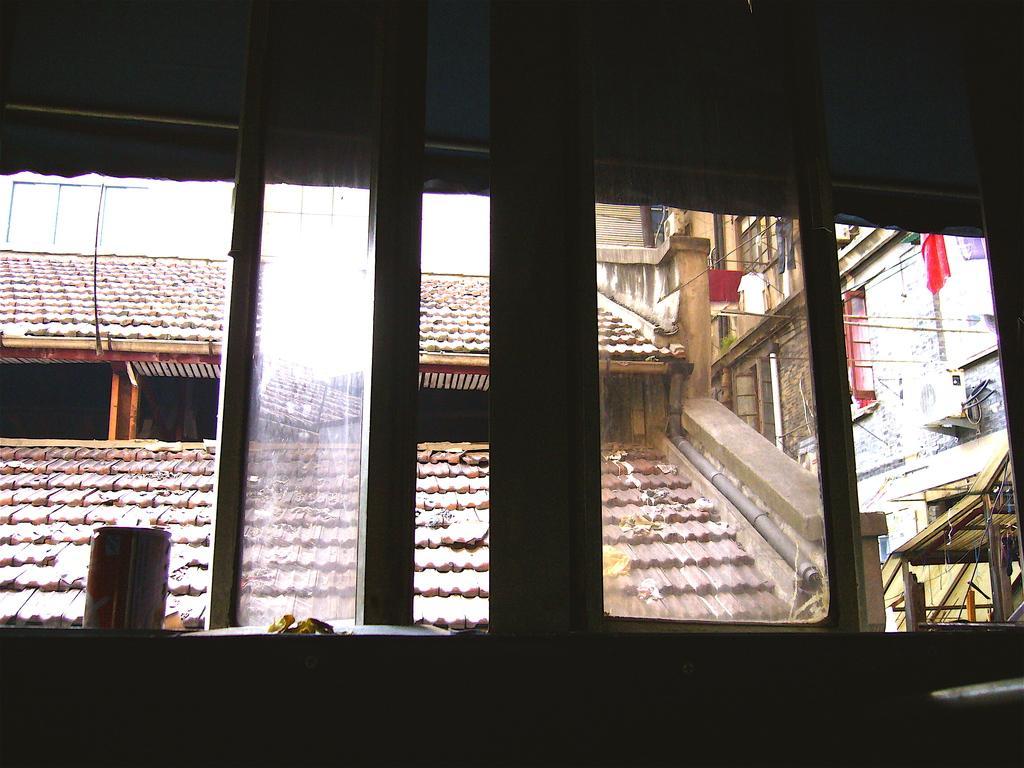How would you summarize this image in a sentence or two? This image is taken indoors. At the bottom of the image there is a wall with windows and through the windows we can see can see there is a house and there is a building with walls, windows and there is a roof. 